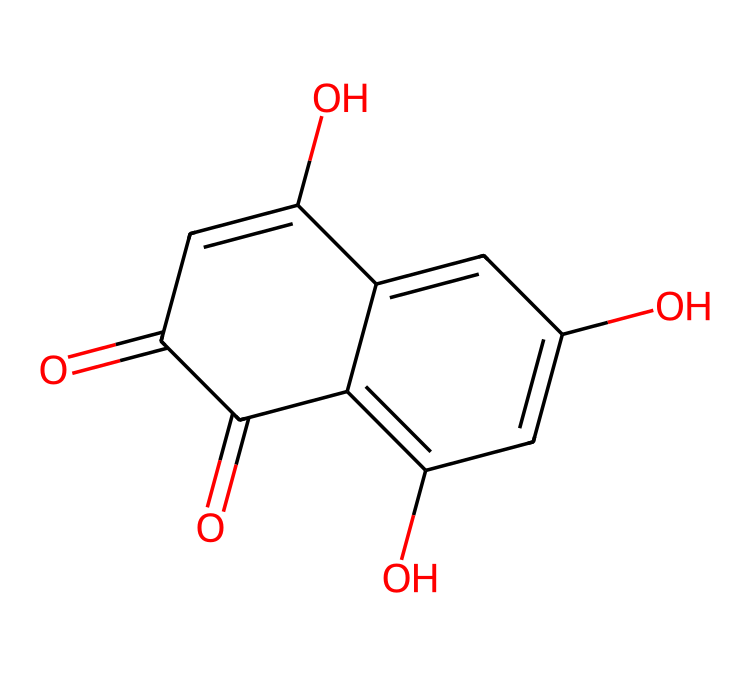What is the main functional group in this compound? Analyzing the structure, the presence of the carbonyl group (C=O) confirms that this compound contains ketones. The visible functional groups in the structure support this.
Answer: ketone How many hydroxyl groups are present in this chemical? By examining the structure, it can be observed that there are three distinct hydroxyl groups (-OH) indicated by the presence of oxygen atoms bonded to hydrogen atoms in the molecular structure.
Answer: three What is the molecular formula of this compound? To derive the molecular formula, count the total number of carbon, hydrogen, and oxygen atoms in the structure. From the SMILES representation, it is determined that there are 10 carbons, 8 hydrogens, and 4 oxygens, which gives the formula C10H8O4.
Answer: C10H8O4 What type of dye is represented by this chemical structure? The structure shows features typical of natural dyes derived from plant sources, specifically a phenolic compound, confirming that it is a botanical dye used in body art like henna.
Answer: botanical dye Does this chemical have any chromophores that might contribute to its color? Yes, the conjugated double bonds and hydroxyl groups present in the structure act as chromophores. These features allow the compound to absorb visible light, leading to color when used as a dye.
Answer: yes What is the significance of this chemical in ancient Egyptian body art? The chemical is significant as it historically served as a natural dye in body art, imparting color to the skin and hair, producing visual symbolism in rituals and aesthetic practices in ancient Egyptian culture.
Answer: body art 